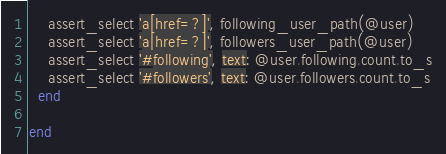Convert code to text. <code><loc_0><loc_0><loc_500><loc_500><_Ruby_>    assert_select 'a[href=?]', following_user_path(@user)
    assert_select 'a[href=?]', followers_user_path(@user)
    assert_select '#following', text: @user.following.count.to_s
    assert_select '#followers', text: @user.followers.count.to_s
  end

end
</code> 